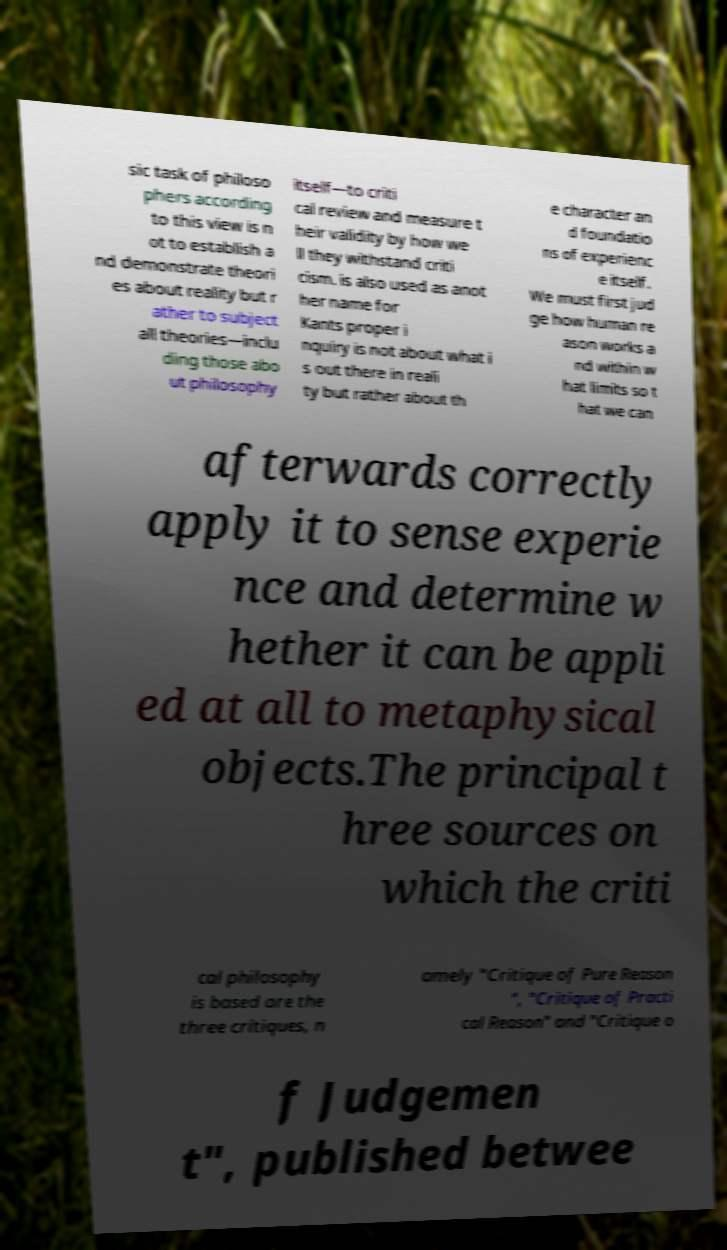What messages or text are displayed in this image? I need them in a readable, typed format. sic task of philoso phers according to this view is n ot to establish a nd demonstrate theori es about reality but r ather to subject all theories—inclu ding those abo ut philosophy itself—to criti cal review and measure t heir validity by how we ll they withstand criti cism. is also used as anot her name for Kants proper i nquiry is not about what i s out there in reali ty but rather about th e character an d foundatio ns of experienc e itself. We must first jud ge how human re ason works a nd within w hat limits so t hat we can afterwards correctly apply it to sense experie nce and determine w hether it can be appli ed at all to metaphysical objects.The principal t hree sources on which the criti cal philosophy is based are the three critiques, n amely "Critique of Pure Reason ", "Critique of Practi cal Reason" and "Critique o f Judgemen t", published betwee 